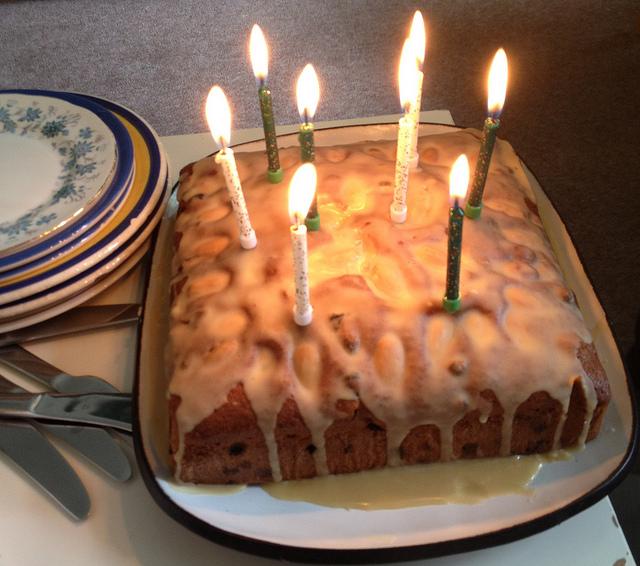What is written on the candles?
Give a very brief answer. Nothing. Is this cake for a teenager?
Answer briefly. No. Does this cake contain high levels of sugar?
Concise answer only. Yes. Are those candles curly?
Keep it brief. No. How many candles are there?
Write a very short answer. 8. 